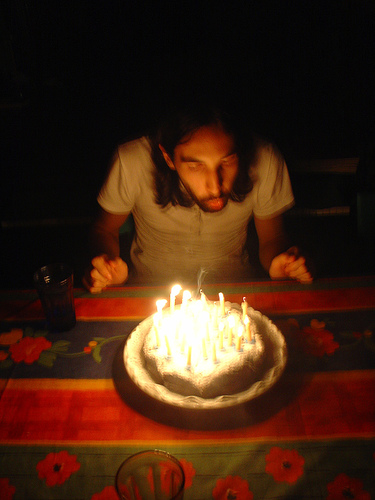<image>
Can you confirm if the man is on the cake? No. The man is not positioned on the cake. They may be near each other, but the man is not supported by or resting on top of the cake. Where is the man in relation to the fire? Is it on the fire? No. The man is not positioned on the fire. They may be near each other, but the man is not supported by or resting on top of the fire. Is there a cake behind the man? No. The cake is not behind the man. From this viewpoint, the cake appears to be positioned elsewhere in the scene. Is the man next to the cake? Yes. The man is positioned adjacent to the cake, located nearby in the same general area. Is the candle in front of the candle? Yes. The candle is positioned in front of the candle, appearing closer to the camera viewpoint. 